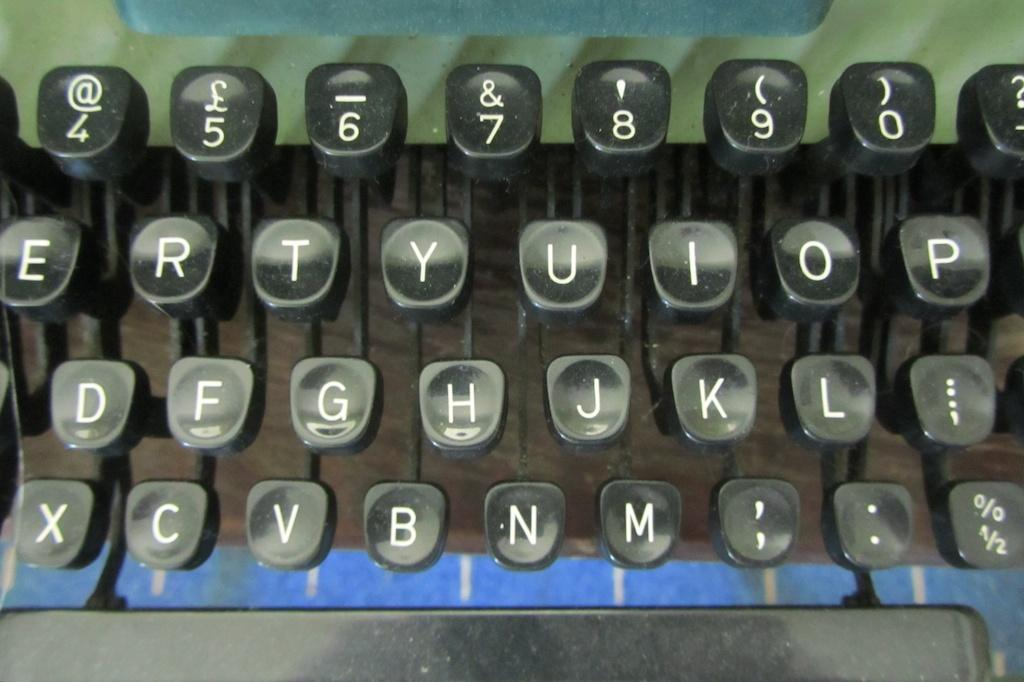Provide a one-sentence caption for the provided image. An old manual keyboard's keys showing partial rows such as ERTYUIOP on the top. 